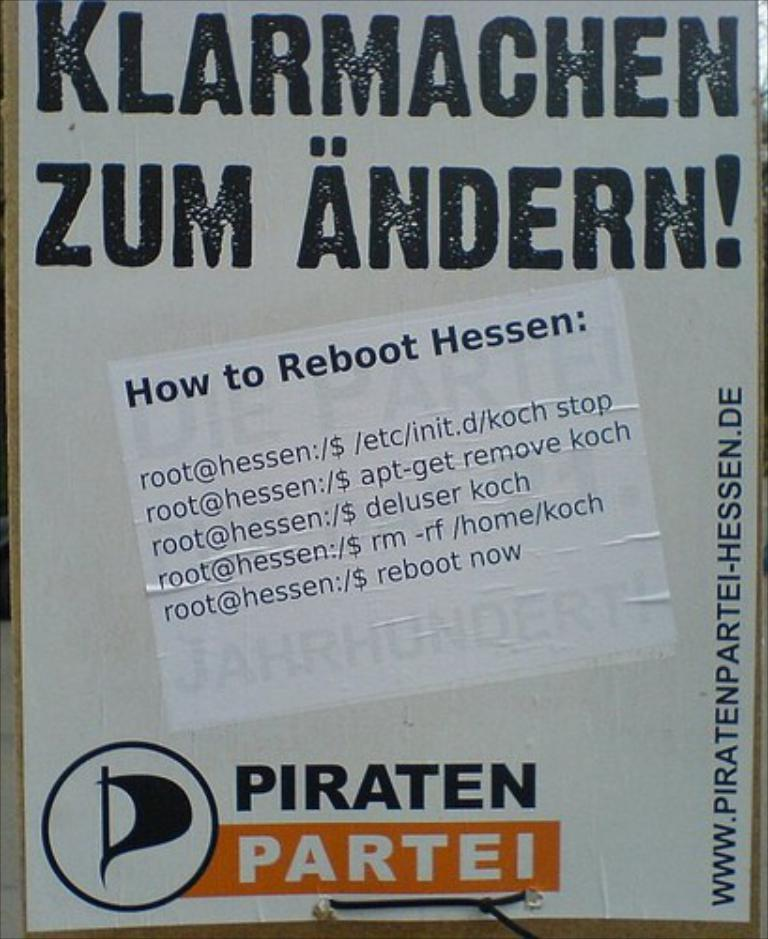<image>
Present a compact description of the photo's key features. Sign that has the words "Klarmachen Zum Andern!" in large black letters. 